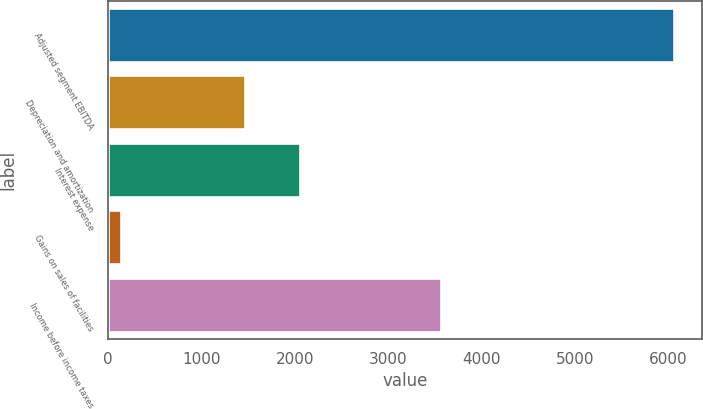Convert chart to OTSL. <chart><loc_0><loc_0><loc_500><loc_500><bar_chart><fcel>Adjusted segment EBITDA<fcel>Depreciation and amortization<fcel>Interest expense<fcel>Gains on sales of facilities<fcel>Income before income taxes<nl><fcel>6061<fcel>1465<fcel>2056.9<fcel>142<fcel>3561<nl></chart> 